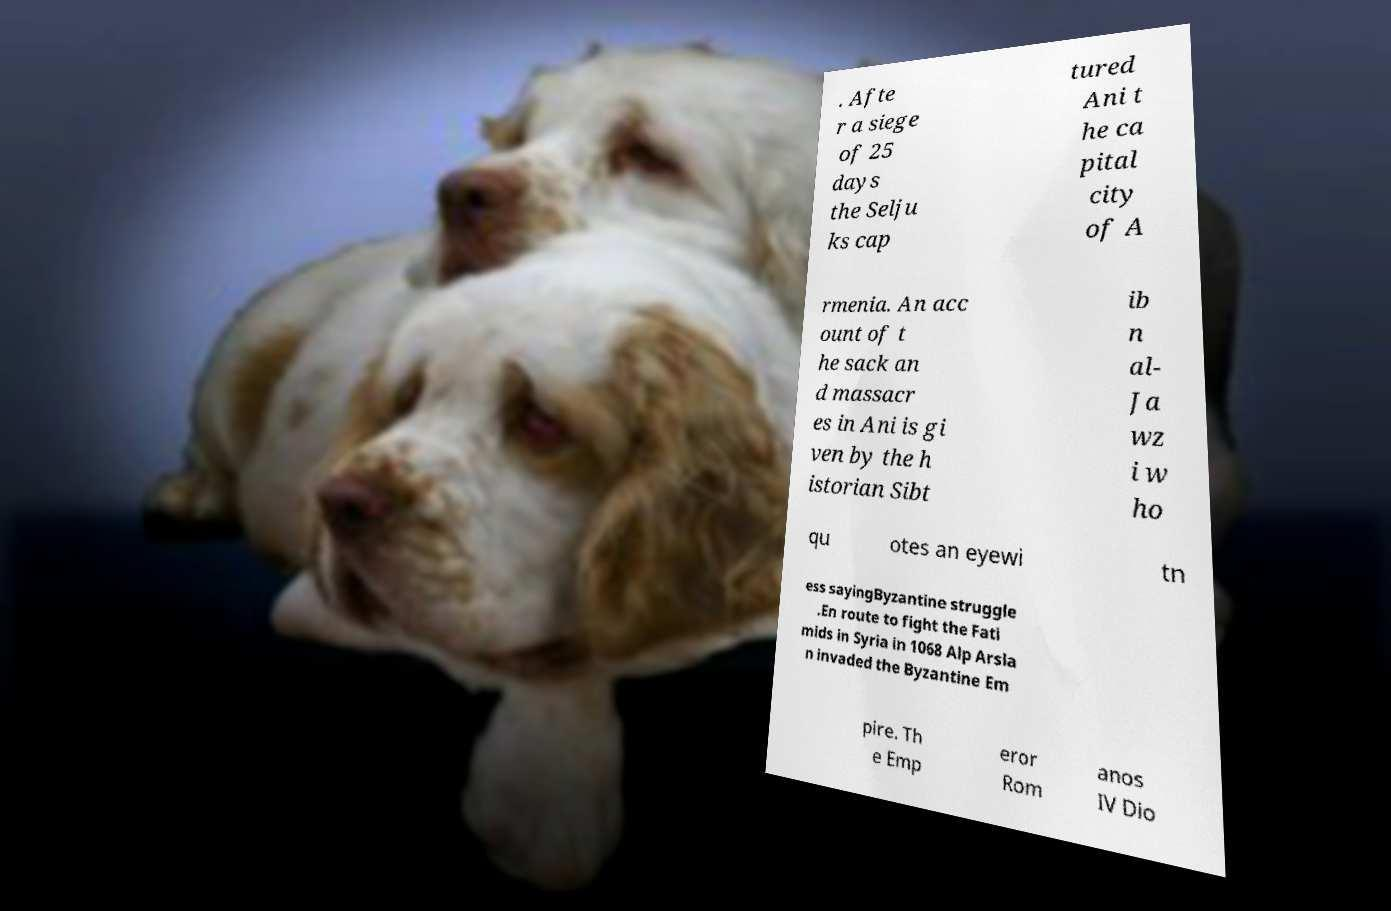There's text embedded in this image that I need extracted. Can you transcribe it verbatim? . Afte r a siege of 25 days the Selju ks cap tured Ani t he ca pital city of A rmenia. An acc ount of t he sack an d massacr es in Ani is gi ven by the h istorian Sibt ib n al- Ja wz i w ho qu otes an eyewi tn ess sayingByzantine struggle .En route to fight the Fati mids in Syria in 1068 Alp Arsla n invaded the Byzantine Em pire. Th e Emp eror Rom anos IV Dio 